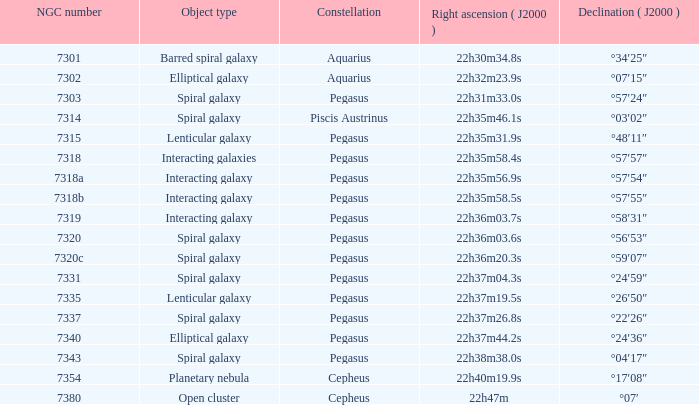What is Pegasus' right ascension with a 7318a NGC? 22h35m56.9s. 